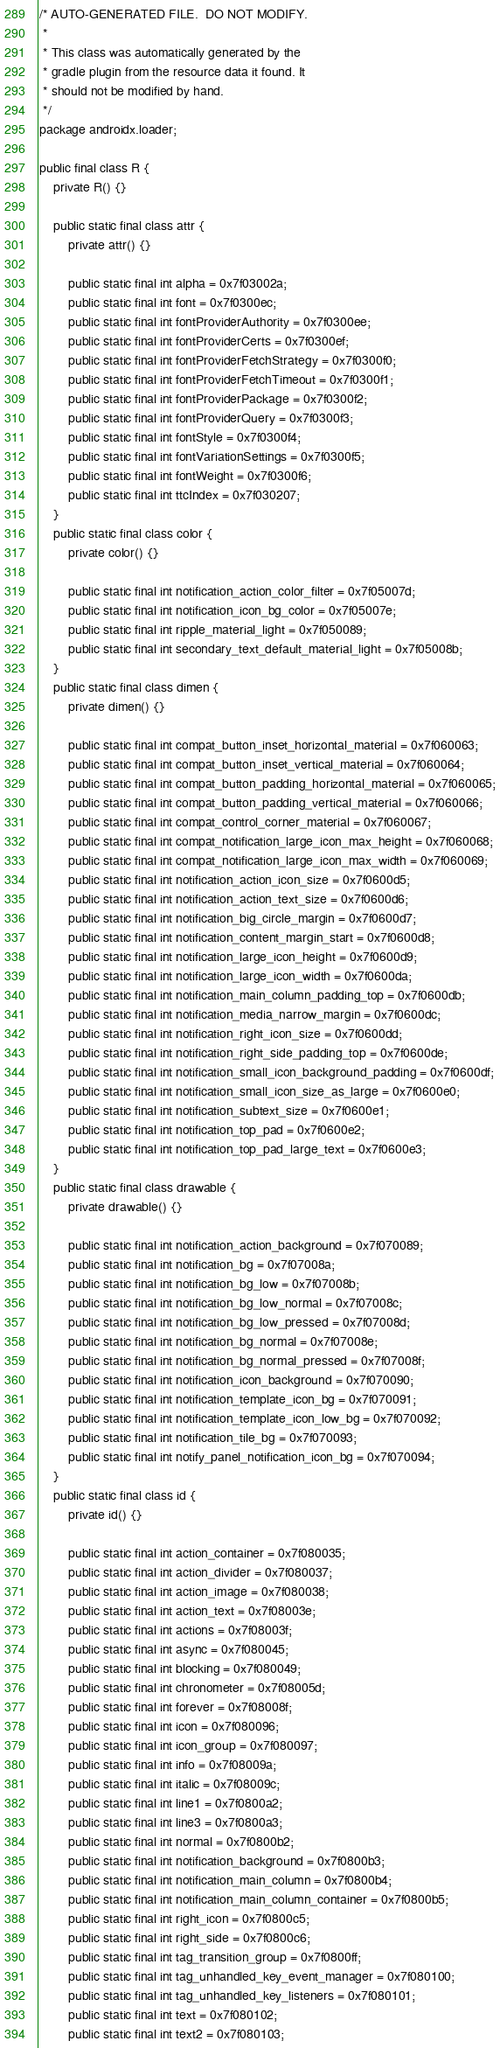Convert code to text. <code><loc_0><loc_0><loc_500><loc_500><_Java_>/* AUTO-GENERATED FILE.  DO NOT MODIFY.
 *
 * This class was automatically generated by the
 * gradle plugin from the resource data it found. It
 * should not be modified by hand.
 */
package androidx.loader;

public final class R {
    private R() {}

    public static final class attr {
        private attr() {}

        public static final int alpha = 0x7f03002a;
        public static final int font = 0x7f0300ec;
        public static final int fontProviderAuthority = 0x7f0300ee;
        public static final int fontProviderCerts = 0x7f0300ef;
        public static final int fontProviderFetchStrategy = 0x7f0300f0;
        public static final int fontProviderFetchTimeout = 0x7f0300f1;
        public static final int fontProviderPackage = 0x7f0300f2;
        public static final int fontProviderQuery = 0x7f0300f3;
        public static final int fontStyle = 0x7f0300f4;
        public static final int fontVariationSettings = 0x7f0300f5;
        public static final int fontWeight = 0x7f0300f6;
        public static final int ttcIndex = 0x7f030207;
    }
    public static final class color {
        private color() {}

        public static final int notification_action_color_filter = 0x7f05007d;
        public static final int notification_icon_bg_color = 0x7f05007e;
        public static final int ripple_material_light = 0x7f050089;
        public static final int secondary_text_default_material_light = 0x7f05008b;
    }
    public static final class dimen {
        private dimen() {}

        public static final int compat_button_inset_horizontal_material = 0x7f060063;
        public static final int compat_button_inset_vertical_material = 0x7f060064;
        public static final int compat_button_padding_horizontal_material = 0x7f060065;
        public static final int compat_button_padding_vertical_material = 0x7f060066;
        public static final int compat_control_corner_material = 0x7f060067;
        public static final int compat_notification_large_icon_max_height = 0x7f060068;
        public static final int compat_notification_large_icon_max_width = 0x7f060069;
        public static final int notification_action_icon_size = 0x7f0600d5;
        public static final int notification_action_text_size = 0x7f0600d6;
        public static final int notification_big_circle_margin = 0x7f0600d7;
        public static final int notification_content_margin_start = 0x7f0600d8;
        public static final int notification_large_icon_height = 0x7f0600d9;
        public static final int notification_large_icon_width = 0x7f0600da;
        public static final int notification_main_column_padding_top = 0x7f0600db;
        public static final int notification_media_narrow_margin = 0x7f0600dc;
        public static final int notification_right_icon_size = 0x7f0600dd;
        public static final int notification_right_side_padding_top = 0x7f0600de;
        public static final int notification_small_icon_background_padding = 0x7f0600df;
        public static final int notification_small_icon_size_as_large = 0x7f0600e0;
        public static final int notification_subtext_size = 0x7f0600e1;
        public static final int notification_top_pad = 0x7f0600e2;
        public static final int notification_top_pad_large_text = 0x7f0600e3;
    }
    public static final class drawable {
        private drawable() {}

        public static final int notification_action_background = 0x7f070089;
        public static final int notification_bg = 0x7f07008a;
        public static final int notification_bg_low = 0x7f07008b;
        public static final int notification_bg_low_normal = 0x7f07008c;
        public static final int notification_bg_low_pressed = 0x7f07008d;
        public static final int notification_bg_normal = 0x7f07008e;
        public static final int notification_bg_normal_pressed = 0x7f07008f;
        public static final int notification_icon_background = 0x7f070090;
        public static final int notification_template_icon_bg = 0x7f070091;
        public static final int notification_template_icon_low_bg = 0x7f070092;
        public static final int notification_tile_bg = 0x7f070093;
        public static final int notify_panel_notification_icon_bg = 0x7f070094;
    }
    public static final class id {
        private id() {}

        public static final int action_container = 0x7f080035;
        public static final int action_divider = 0x7f080037;
        public static final int action_image = 0x7f080038;
        public static final int action_text = 0x7f08003e;
        public static final int actions = 0x7f08003f;
        public static final int async = 0x7f080045;
        public static final int blocking = 0x7f080049;
        public static final int chronometer = 0x7f08005d;
        public static final int forever = 0x7f08008f;
        public static final int icon = 0x7f080096;
        public static final int icon_group = 0x7f080097;
        public static final int info = 0x7f08009a;
        public static final int italic = 0x7f08009c;
        public static final int line1 = 0x7f0800a2;
        public static final int line3 = 0x7f0800a3;
        public static final int normal = 0x7f0800b2;
        public static final int notification_background = 0x7f0800b3;
        public static final int notification_main_column = 0x7f0800b4;
        public static final int notification_main_column_container = 0x7f0800b5;
        public static final int right_icon = 0x7f0800c5;
        public static final int right_side = 0x7f0800c6;
        public static final int tag_transition_group = 0x7f0800ff;
        public static final int tag_unhandled_key_event_manager = 0x7f080100;
        public static final int tag_unhandled_key_listeners = 0x7f080101;
        public static final int text = 0x7f080102;
        public static final int text2 = 0x7f080103;</code> 